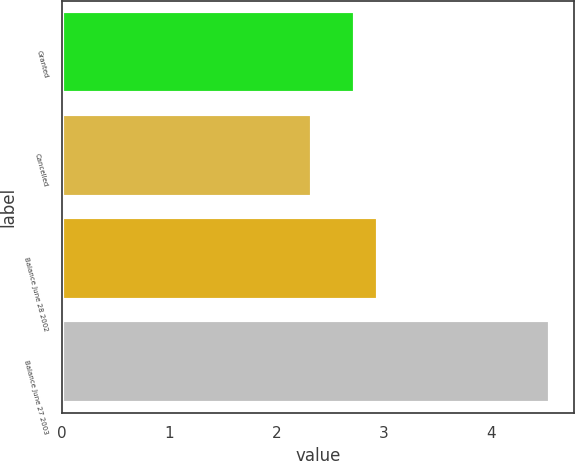<chart> <loc_0><loc_0><loc_500><loc_500><bar_chart><fcel>Granted<fcel>Cancelled<fcel>Balance June 28 2002<fcel>Balance June 27 2003<nl><fcel>2.73<fcel>2.33<fcel>2.95<fcel>4.55<nl></chart> 